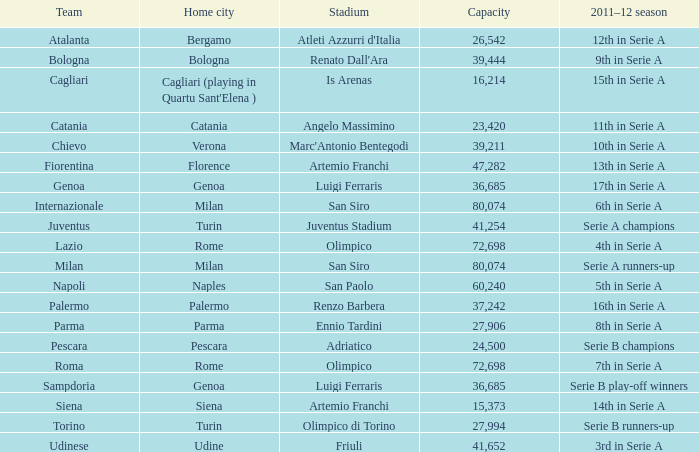In the 2011-2012 serie a season, which milan-based team with a capacity exceeding 26,542 finished in 6th place? Internazionale. 